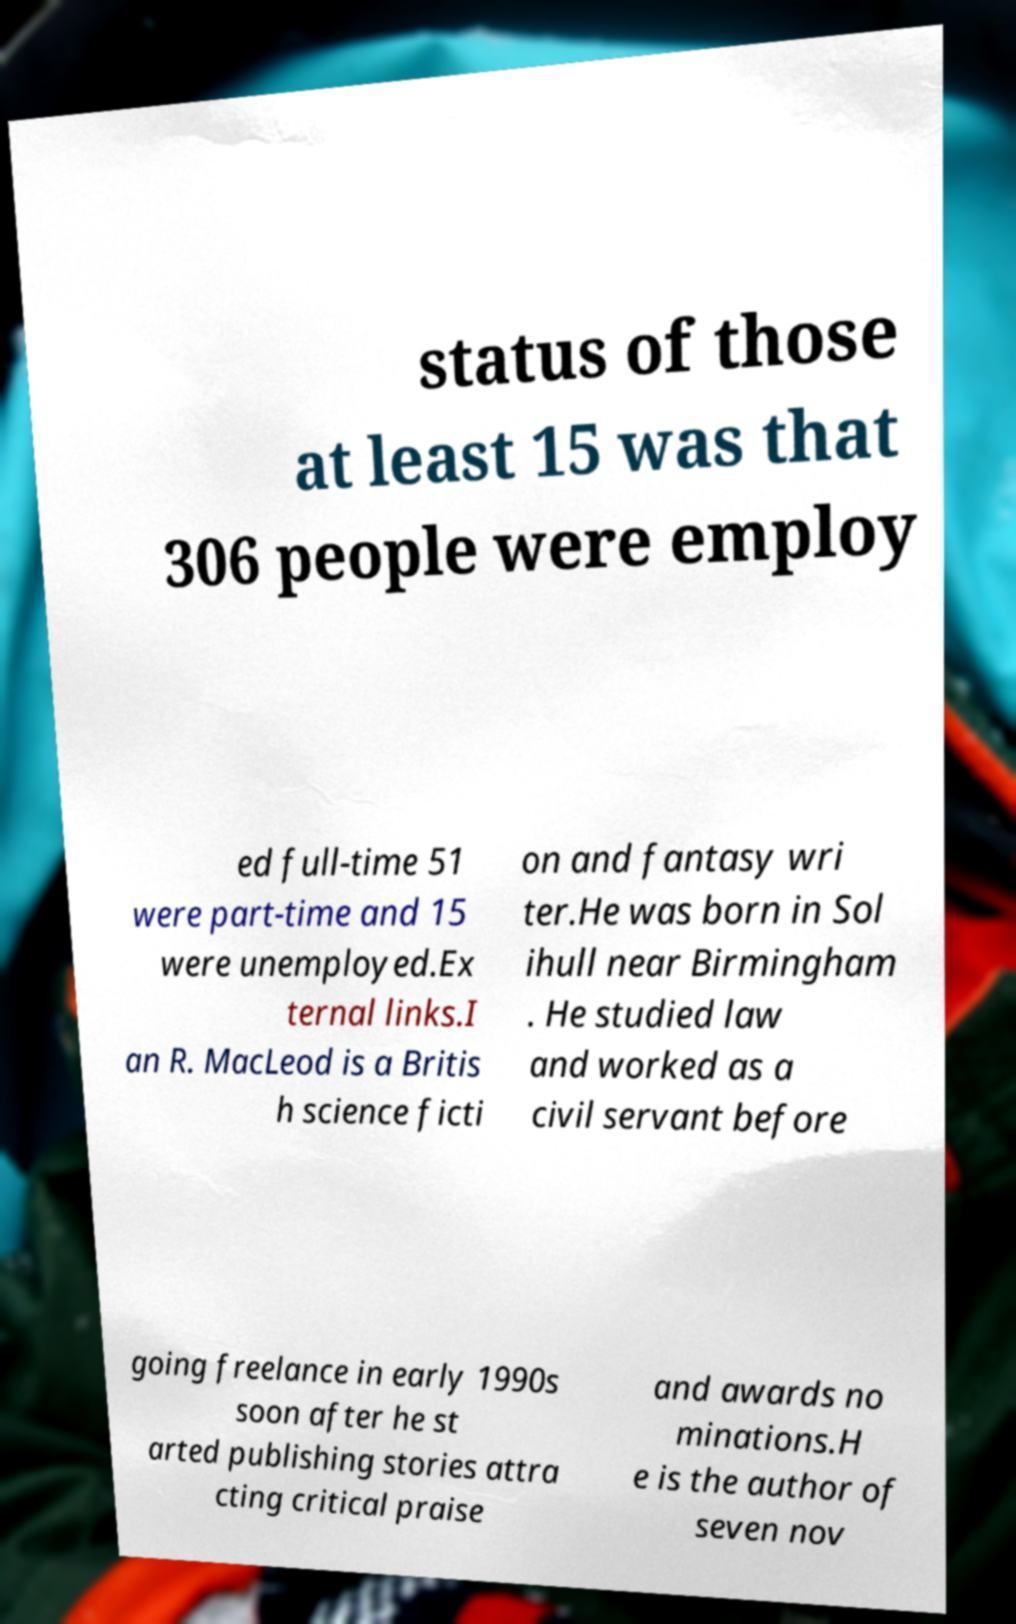Can you read and provide the text displayed in the image?This photo seems to have some interesting text. Can you extract and type it out for me? status of those at least 15 was that 306 people were employ ed full-time 51 were part-time and 15 were unemployed.Ex ternal links.I an R. MacLeod is a Britis h science ficti on and fantasy wri ter.He was born in Sol ihull near Birmingham . He studied law and worked as a civil servant before going freelance in early 1990s soon after he st arted publishing stories attra cting critical praise and awards no minations.H e is the author of seven nov 